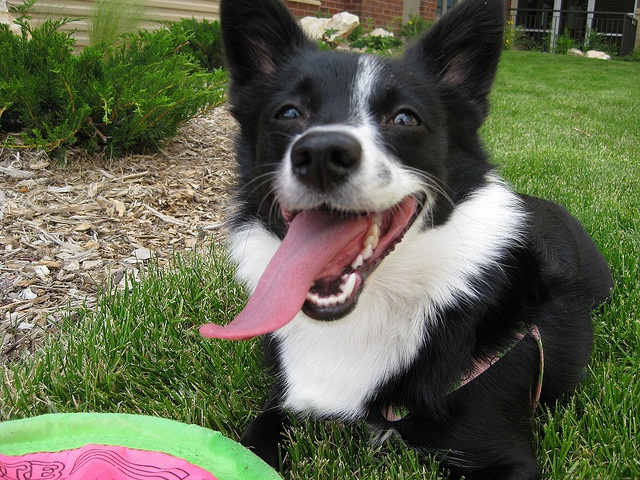Describe the objects in this image and their specific colors. I can see dog in darkgray, black, gainsboro, and gray tones and frisbee in darkgray, lightgreen, and violet tones in this image. 